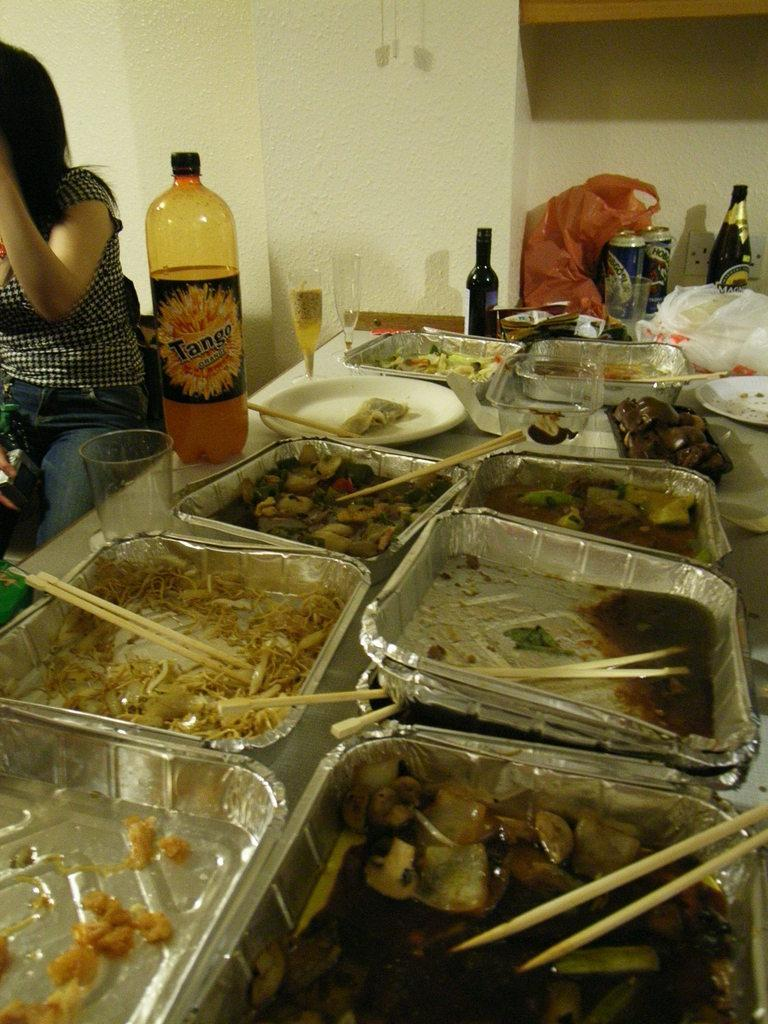What is present in the image that people might sit at? There is a table in the image. What can be seen on the table? There is leftover food, a cool drink bottle, and coke tins on the table. Can you describe the person sitting beside the table? There is a girl sitting beside the table. How far did the girl travel to reach the table in the image? The provided facts do not mention any information about the girl's journey or distance traveled, so we cannot determine this information from the image. 